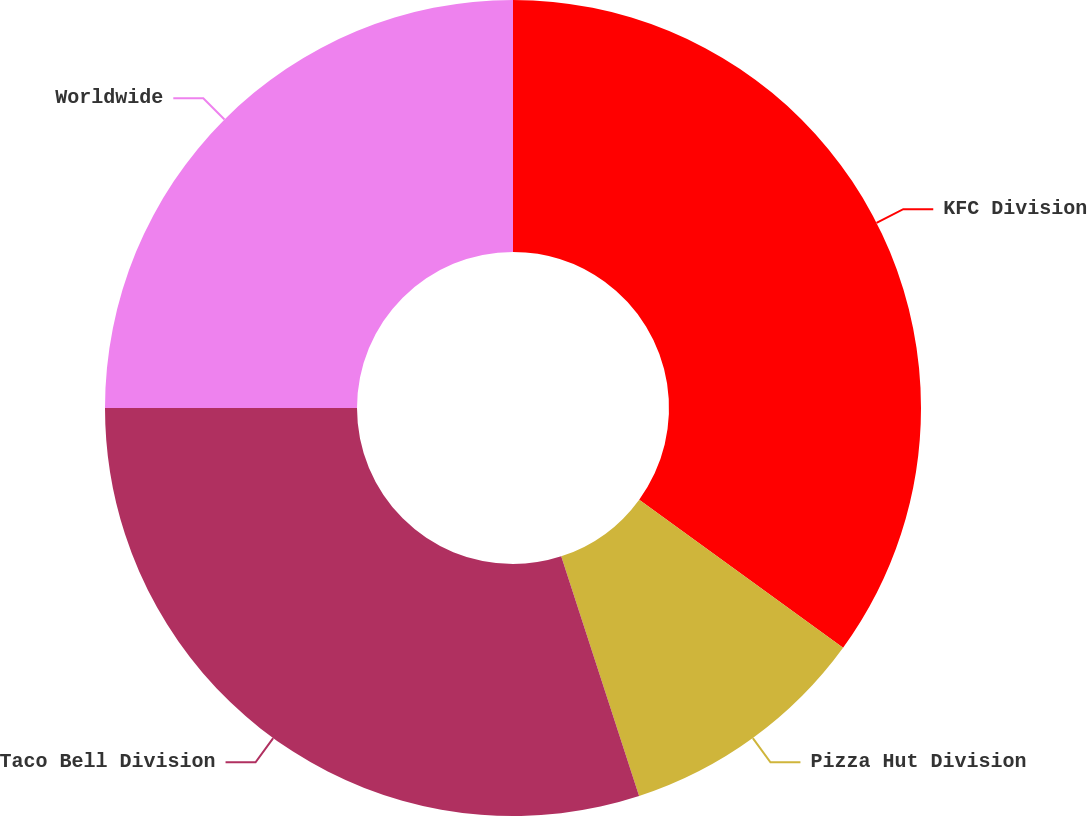Convert chart. <chart><loc_0><loc_0><loc_500><loc_500><pie_chart><fcel>KFC Division<fcel>Pizza Hut Division<fcel>Taco Bell Division<fcel>Worldwide<nl><fcel>35.0%<fcel>10.0%<fcel>30.0%<fcel>25.0%<nl></chart> 